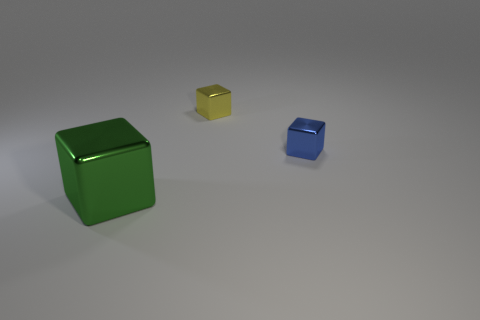What time of day does the lighting in this image suggest? The lighting in the image does not provide clear indications of the time of day. It seems to be a constructed scenario with controlled lighting, as often found in a studio setting. 